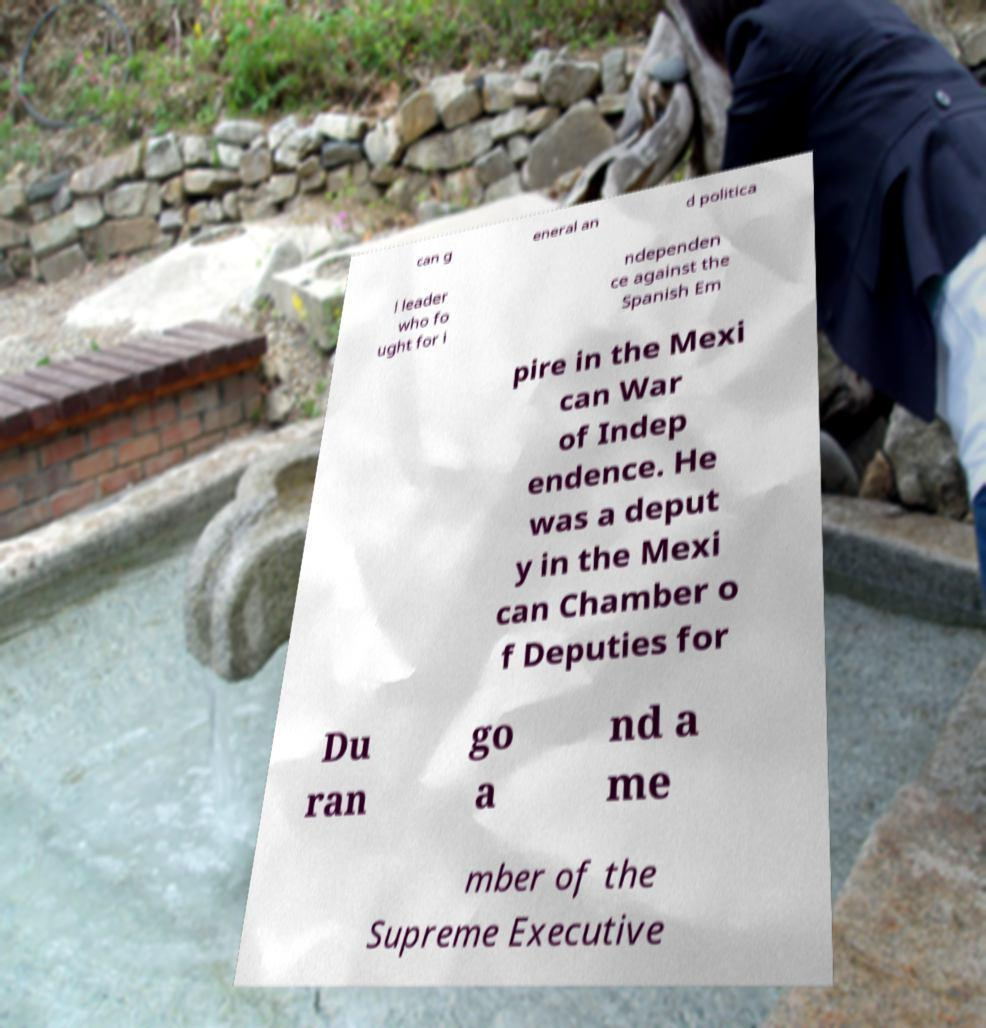There's text embedded in this image that I need extracted. Can you transcribe it verbatim? can g eneral an d politica l leader who fo ught for i ndependen ce against the Spanish Em pire in the Mexi can War of Indep endence. He was a deput y in the Mexi can Chamber o f Deputies for Du ran go a nd a me mber of the Supreme Executive 